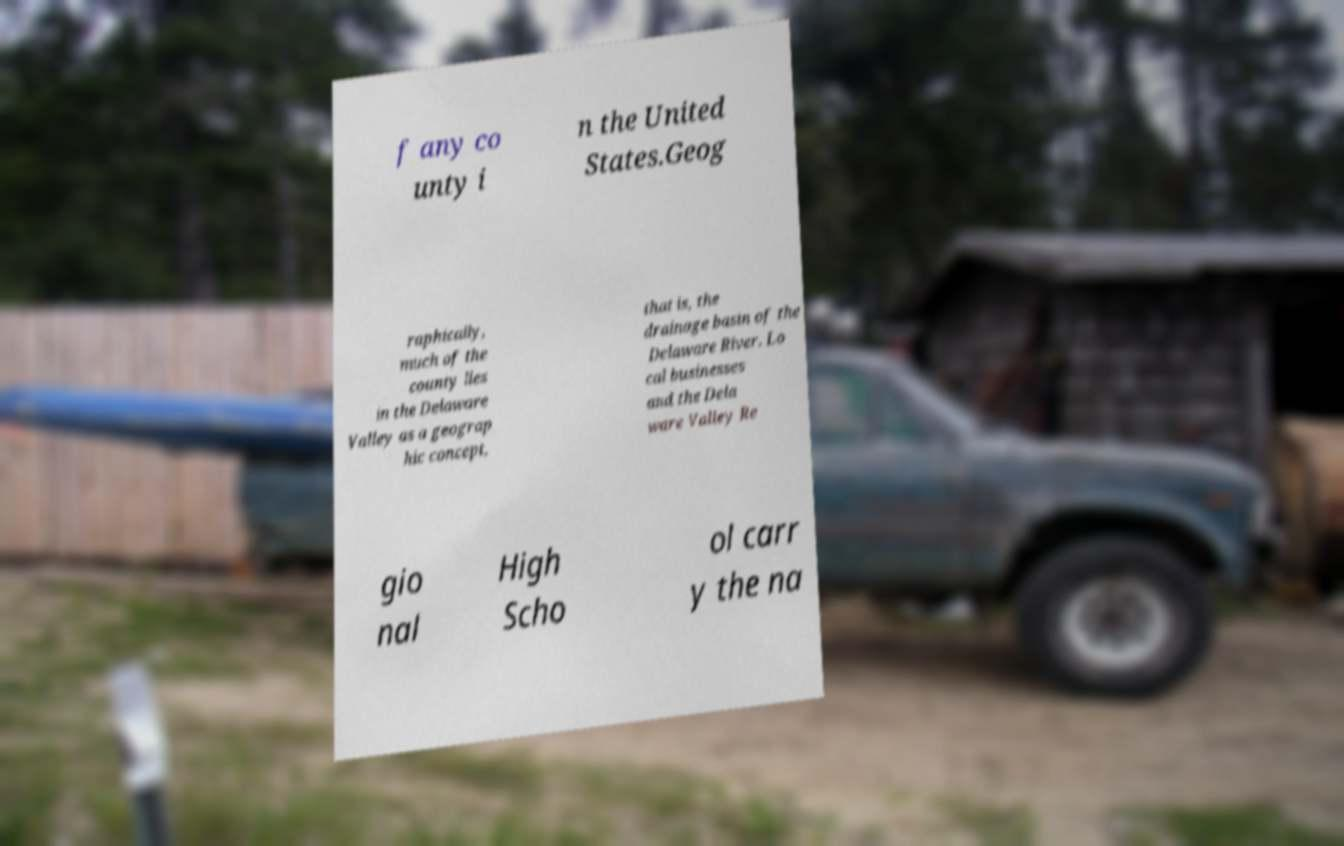What messages or text are displayed in this image? I need them in a readable, typed format. f any co unty i n the United States.Geog raphically, much of the county lies in the Delaware Valley as a geograp hic concept, that is, the drainage basin of the Delaware River. Lo cal businesses and the Dela ware Valley Re gio nal High Scho ol carr y the na 